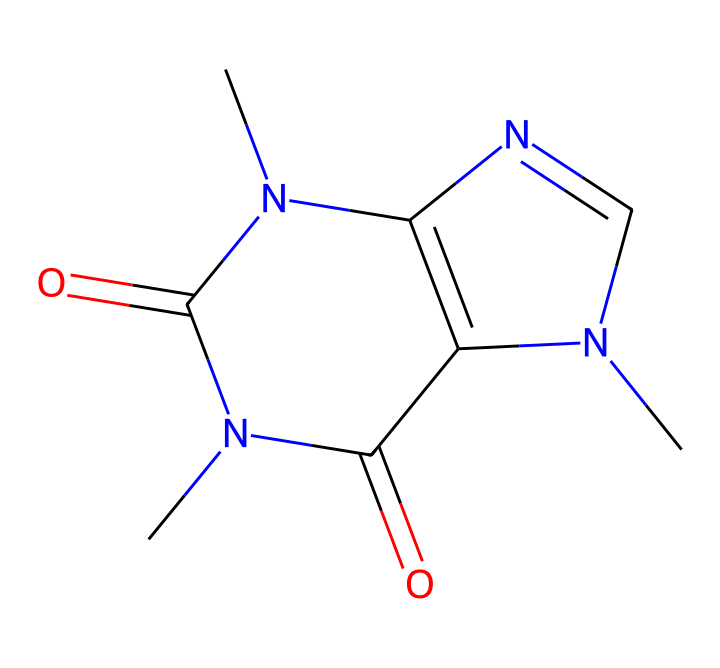What is the total number of nitrogen atoms in the chemical structure? By analyzing the SMILES representation, there are two nitrogen atoms present, which can be identified by the 'N' characters in the formula.
Answer: 2 What are the total number of rings in the chemical structure? In the provided SMILES, we can recognize that there are two cyclic structures indicated by the presence of 'N1' and 'N2', suggesting that the compound forms two interconnected rings.
Answer: 2 What type of chemical is represented by this structure? This chemical is a stimulant, specifically categorized as an alkaloid, primarily due to the presence of nitrogen atoms which are common in many stimulants.
Answer: alkaloid What is the molecular formula derived from the structure? By decoding the SMILES notation, the components and their quantities can be counted; this reveals a molecular formula of C8H10N4O2.
Answer: C8H10N4O2 Which specific functional groups are present in this structure? The chemical contains carbonyl groups (C=O) and amine groups (–NH, indicated by nitrogen), identifiable from the arrangement in the SMILES structure.
Answer: carbonyl, amine How many total carbon atoms are in the structure? Counting the 'C' symbols in the SMILES string, there are eight carbon atoms in total present in this chemical compound.
Answer: 8 What role does the nitrogen play in this chemical? In this structure, the nitrogen atoms contribute to the basic properties of the compound, such as its ability to act as a stimulant due to their presence in the alkaloid group, influencing the molecule's interactions in biological systems.
Answer: stimulant 